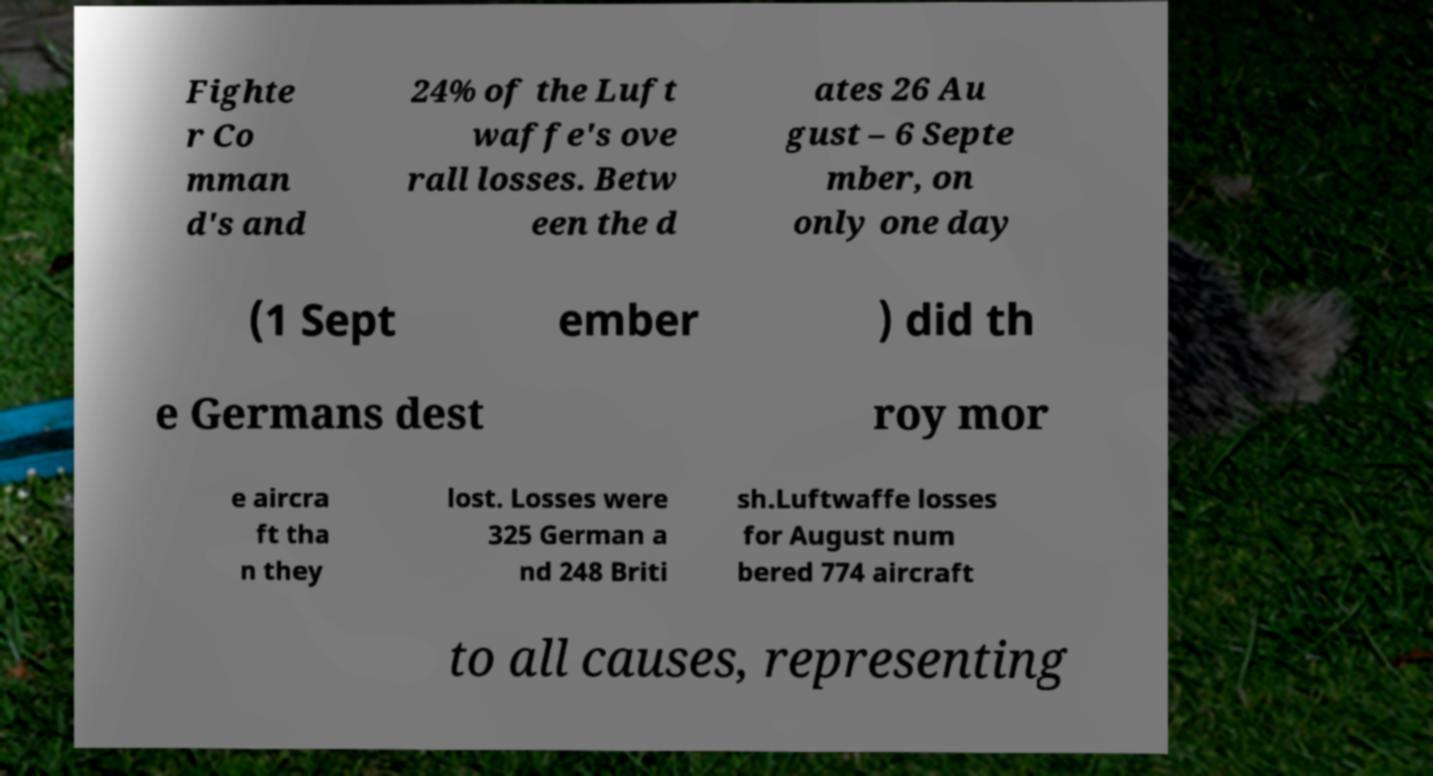Can you read and provide the text displayed in the image?This photo seems to have some interesting text. Can you extract and type it out for me? Fighte r Co mman d's and 24% of the Luft waffe's ove rall losses. Betw een the d ates 26 Au gust – 6 Septe mber, on only one day (1 Sept ember ) did th e Germans dest roy mor e aircra ft tha n they lost. Losses were 325 German a nd 248 Briti sh.Luftwaffe losses for August num bered 774 aircraft to all causes, representing 